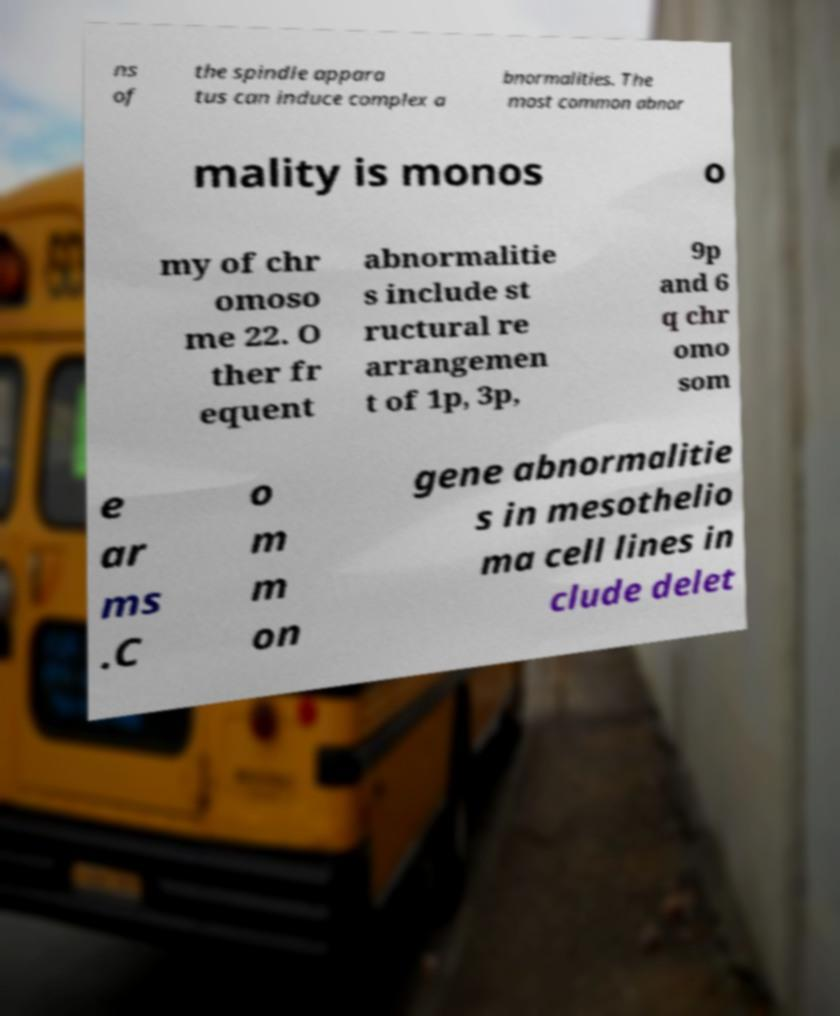There's text embedded in this image that I need extracted. Can you transcribe it verbatim? ns of the spindle appara tus can induce complex a bnormalities. The most common abnor mality is monos o my of chr omoso me 22. O ther fr equent abnormalitie s include st ructural re arrangemen t of 1p, 3p, 9p and 6 q chr omo som e ar ms .C o m m on gene abnormalitie s in mesothelio ma cell lines in clude delet 